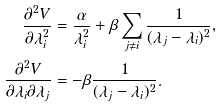<formula> <loc_0><loc_0><loc_500><loc_500>\frac { \partial ^ { 2 } V } { \partial \lambda _ { i } ^ { 2 } } & = \frac { \alpha } { \lambda _ { i } ^ { 2 } } + \beta \sum _ { j \neq i } \frac { 1 } { ( \lambda _ { j } - \lambda _ { i } ) ^ { 2 } } , \\ \frac { \partial ^ { 2 } V } { \partial \lambda _ { i } \partial \lambda _ { j } } & = - \beta \frac { 1 } { ( \lambda _ { j } - \lambda _ { i } ) ^ { 2 } } .</formula> 